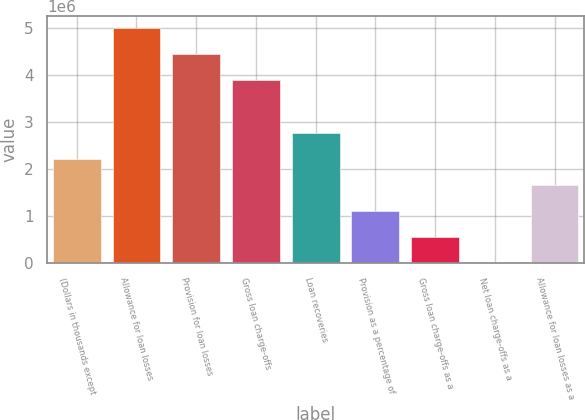Convert chart to OTSL. <chart><loc_0><loc_0><loc_500><loc_500><bar_chart><fcel>(Dollars in thousands except<fcel>Allowance for loan losses<fcel>Provision for loan losses<fcel>Gross loan charge-offs<fcel>Loan recoveries<fcel>Provision as a percentage of<fcel>Gross loan charge-offs as a<fcel>Net loan charge-offs as a<fcel>Allowance for loan losses as a<nl><fcel>2.22065e+06<fcel>4.99647e+06<fcel>4.44131e+06<fcel>3.88615e+06<fcel>2.77582e+06<fcel>1.11033e+06<fcel>555164<fcel>0.87<fcel>1.66549e+06<nl></chart> 